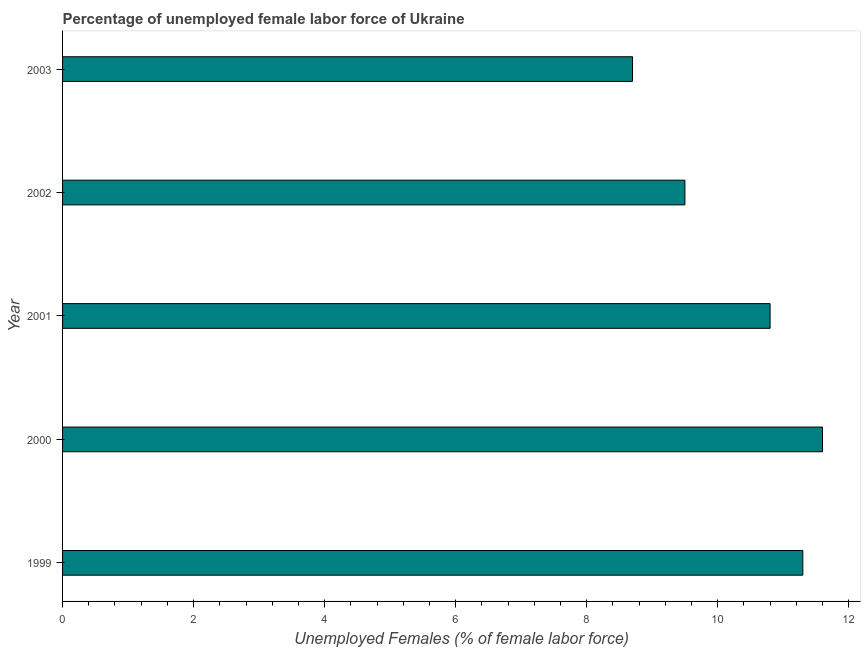Does the graph contain grids?
Keep it short and to the point. No. What is the title of the graph?
Your answer should be very brief. Percentage of unemployed female labor force of Ukraine. What is the label or title of the X-axis?
Keep it short and to the point. Unemployed Females (% of female labor force). What is the label or title of the Y-axis?
Ensure brevity in your answer.  Year. Across all years, what is the maximum total unemployed female labour force?
Offer a terse response. 11.6. Across all years, what is the minimum total unemployed female labour force?
Your response must be concise. 8.7. In which year was the total unemployed female labour force minimum?
Offer a terse response. 2003. What is the sum of the total unemployed female labour force?
Give a very brief answer. 51.9. What is the difference between the total unemployed female labour force in 2000 and 2002?
Offer a very short reply. 2.1. What is the average total unemployed female labour force per year?
Keep it short and to the point. 10.38. What is the median total unemployed female labour force?
Give a very brief answer. 10.8. Do a majority of the years between 2003 and 2001 (inclusive) have total unemployed female labour force greater than 6 %?
Your answer should be compact. Yes. What is the ratio of the total unemployed female labour force in 2000 to that in 2002?
Offer a terse response. 1.22. Is the difference between the total unemployed female labour force in 2001 and 2003 greater than the difference between any two years?
Make the answer very short. No. Is the sum of the total unemployed female labour force in 1999 and 2003 greater than the maximum total unemployed female labour force across all years?
Provide a short and direct response. Yes. What is the difference between the highest and the lowest total unemployed female labour force?
Your answer should be very brief. 2.9. In how many years, is the total unemployed female labour force greater than the average total unemployed female labour force taken over all years?
Provide a short and direct response. 3. How many years are there in the graph?
Provide a short and direct response. 5. What is the difference between two consecutive major ticks on the X-axis?
Your response must be concise. 2. Are the values on the major ticks of X-axis written in scientific E-notation?
Offer a very short reply. No. What is the Unemployed Females (% of female labor force) in 1999?
Your answer should be compact. 11.3. What is the Unemployed Females (% of female labor force) in 2000?
Make the answer very short. 11.6. What is the Unemployed Females (% of female labor force) in 2001?
Make the answer very short. 10.8. What is the Unemployed Females (% of female labor force) in 2003?
Offer a very short reply. 8.7. What is the difference between the Unemployed Females (% of female labor force) in 1999 and 2002?
Provide a succinct answer. 1.8. What is the difference between the Unemployed Females (% of female labor force) in 1999 and 2003?
Your response must be concise. 2.6. What is the difference between the Unemployed Females (% of female labor force) in 2000 and 2002?
Offer a terse response. 2.1. What is the difference between the Unemployed Females (% of female labor force) in 2000 and 2003?
Your response must be concise. 2.9. What is the ratio of the Unemployed Females (% of female labor force) in 1999 to that in 2000?
Offer a terse response. 0.97. What is the ratio of the Unemployed Females (% of female labor force) in 1999 to that in 2001?
Give a very brief answer. 1.05. What is the ratio of the Unemployed Females (% of female labor force) in 1999 to that in 2002?
Your answer should be very brief. 1.19. What is the ratio of the Unemployed Females (% of female labor force) in 1999 to that in 2003?
Provide a short and direct response. 1.3. What is the ratio of the Unemployed Females (% of female labor force) in 2000 to that in 2001?
Offer a very short reply. 1.07. What is the ratio of the Unemployed Females (% of female labor force) in 2000 to that in 2002?
Make the answer very short. 1.22. What is the ratio of the Unemployed Females (% of female labor force) in 2000 to that in 2003?
Offer a very short reply. 1.33. What is the ratio of the Unemployed Females (% of female labor force) in 2001 to that in 2002?
Give a very brief answer. 1.14. What is the ratio of the Unemployed Females (% of female labor force) in 2001 to that in 2003?
Provide a succinct answer. 1.24. What is the ratio of the Unemployed Females (% of female labor force) in 2002 to that in 2003?
Your response must be concise. 1.09. 